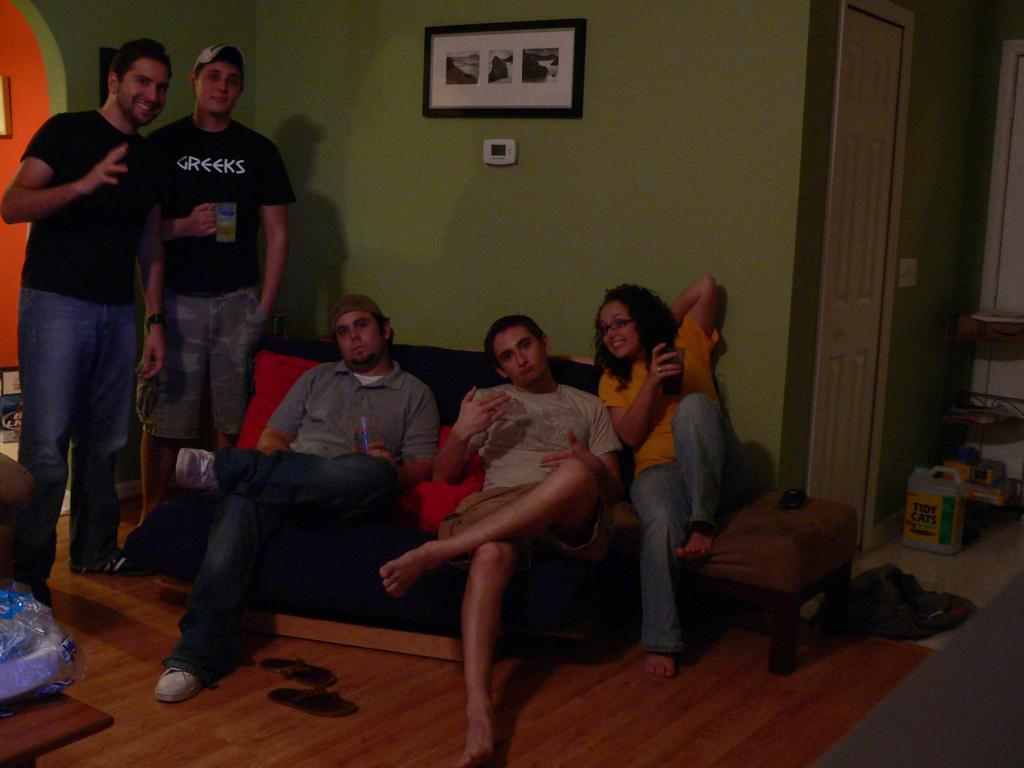What type of structure can be seen in the image? There is a wall in the image. Are there any decorative items visible in the image? Yes, there is a photo frame in the image. What is a common feature of rooms that can be seen in the image? There is a door in the image. Who or what is present in the image? There are people in the image. What type of furniture can be seen in the image? There is a sofa in the image. What object is located on the right side of the image? There is a box on the right side of the image. How many layers of cake can be seen in the image? There is no cake present in the image. What type of grip is being used by the people in the image? There is no specific grip being used by the people in the image; they are simply standing or sitting. 